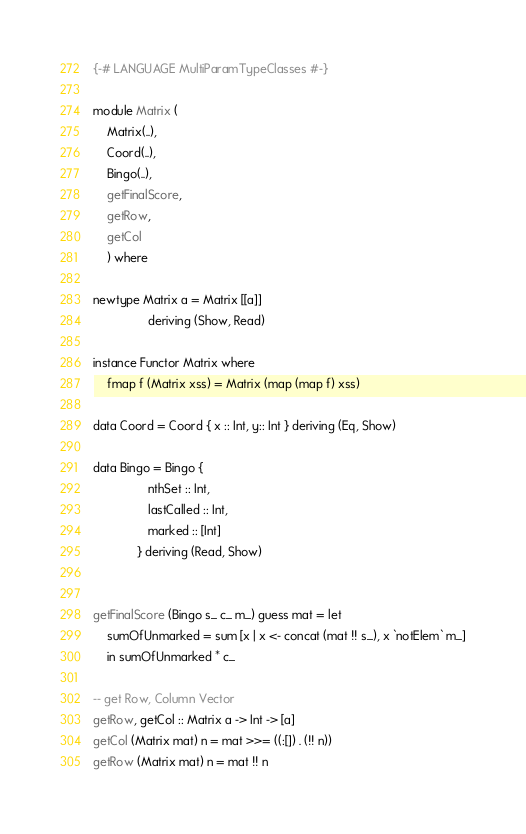Convert code to text. <code><loc_0><loc_0><loc_500><loc_500><_Haskell_>{-# LANGUAGE MultiParamTypeClasses #-}

module Matrix (
    Matrix(..),
    Coord(..),
    Bingo(..),
    getFinalScore,
    getRow,
    getCol
    ) where

newtype Matrix a = Matrix [[a]]
                deriving (Show, Read)

instance Functor Matrix where
    fmap f (Matrix xss) = Matrix (map (map f) xss)

data Coord = Coord { x :: Int, y:: Int } deriving (Eq, Show)

data Bingo = Bingo {
                nthSet :: Int,
                lastCalled :: Int,
                marked :: [Int]
             } deriving (Read, Show)


getFinalScore (Bingo s_ c_ m_) guess mat = let 
    sumOfUnmarked = sum [x | x <- concat (mat !! s_), x `notElem` m_]
    in sumOfUnmarked * c_

-- get Row, Column Vector
getRow, getCol :: Matrix a -> Int -> [a]
getCol (Matrix mat) n = mat >>= ((:[]) . (!! n))
getRow (Matrix mat) n = mat !! n
</code> 